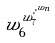Convert formula to latex. <formula><loc_0><loc_0><loc_500><loc_500>w _ { 6 } ^ { w _ { 7 } ^ { \cdot ^ { \cdot ^ { w _ { n } } } } }</formula> 